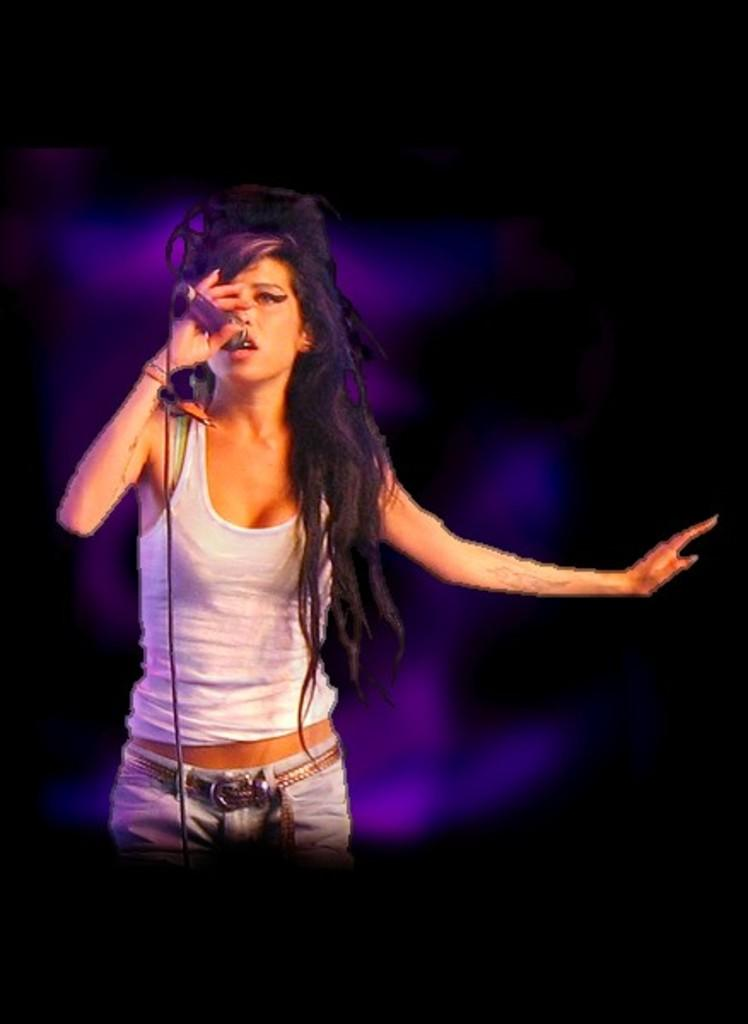Who is the main subject in the image? There is a woman in the image. What is the woman wearing? The woman is wearing a white t-shirt. What is the woman holding in the image? The woman is holding a microphone. What is the woman doing in the image? The woman is singing. What is the position of the woman in the image? The woman is standing. What is the color of the background in the image? The background of the image is dark in color. What type of juice is the woman drinking in the image? There is no juice present in the image; the woman is holding a microphone and singing. What color is the dress the woman is wearing in the image? The woman is not wearing a dress in the image; she is wearing a white t-shirt. 